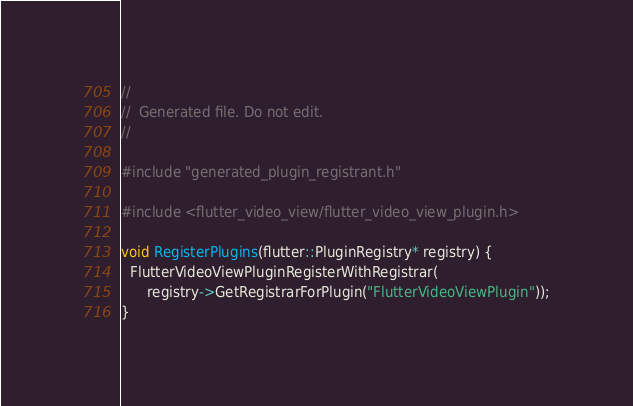<code> <loc_0><loc_0><loc_500><loc_500><_C++_>//
//  Generated file. Do not edit.
//

#include "generated_plugin_registrant.h"

#include <flutter_video_view/flutter_video_view_plugin.h>

void RegisterPlugins(flutter::PluginRegistry* registry) {
  FlutterVideoViewPluginRegisterWithRegistrar(
      registry->GetRegistrarForPlugin("FlutterVideoViewPlugin"));
}
</code> 